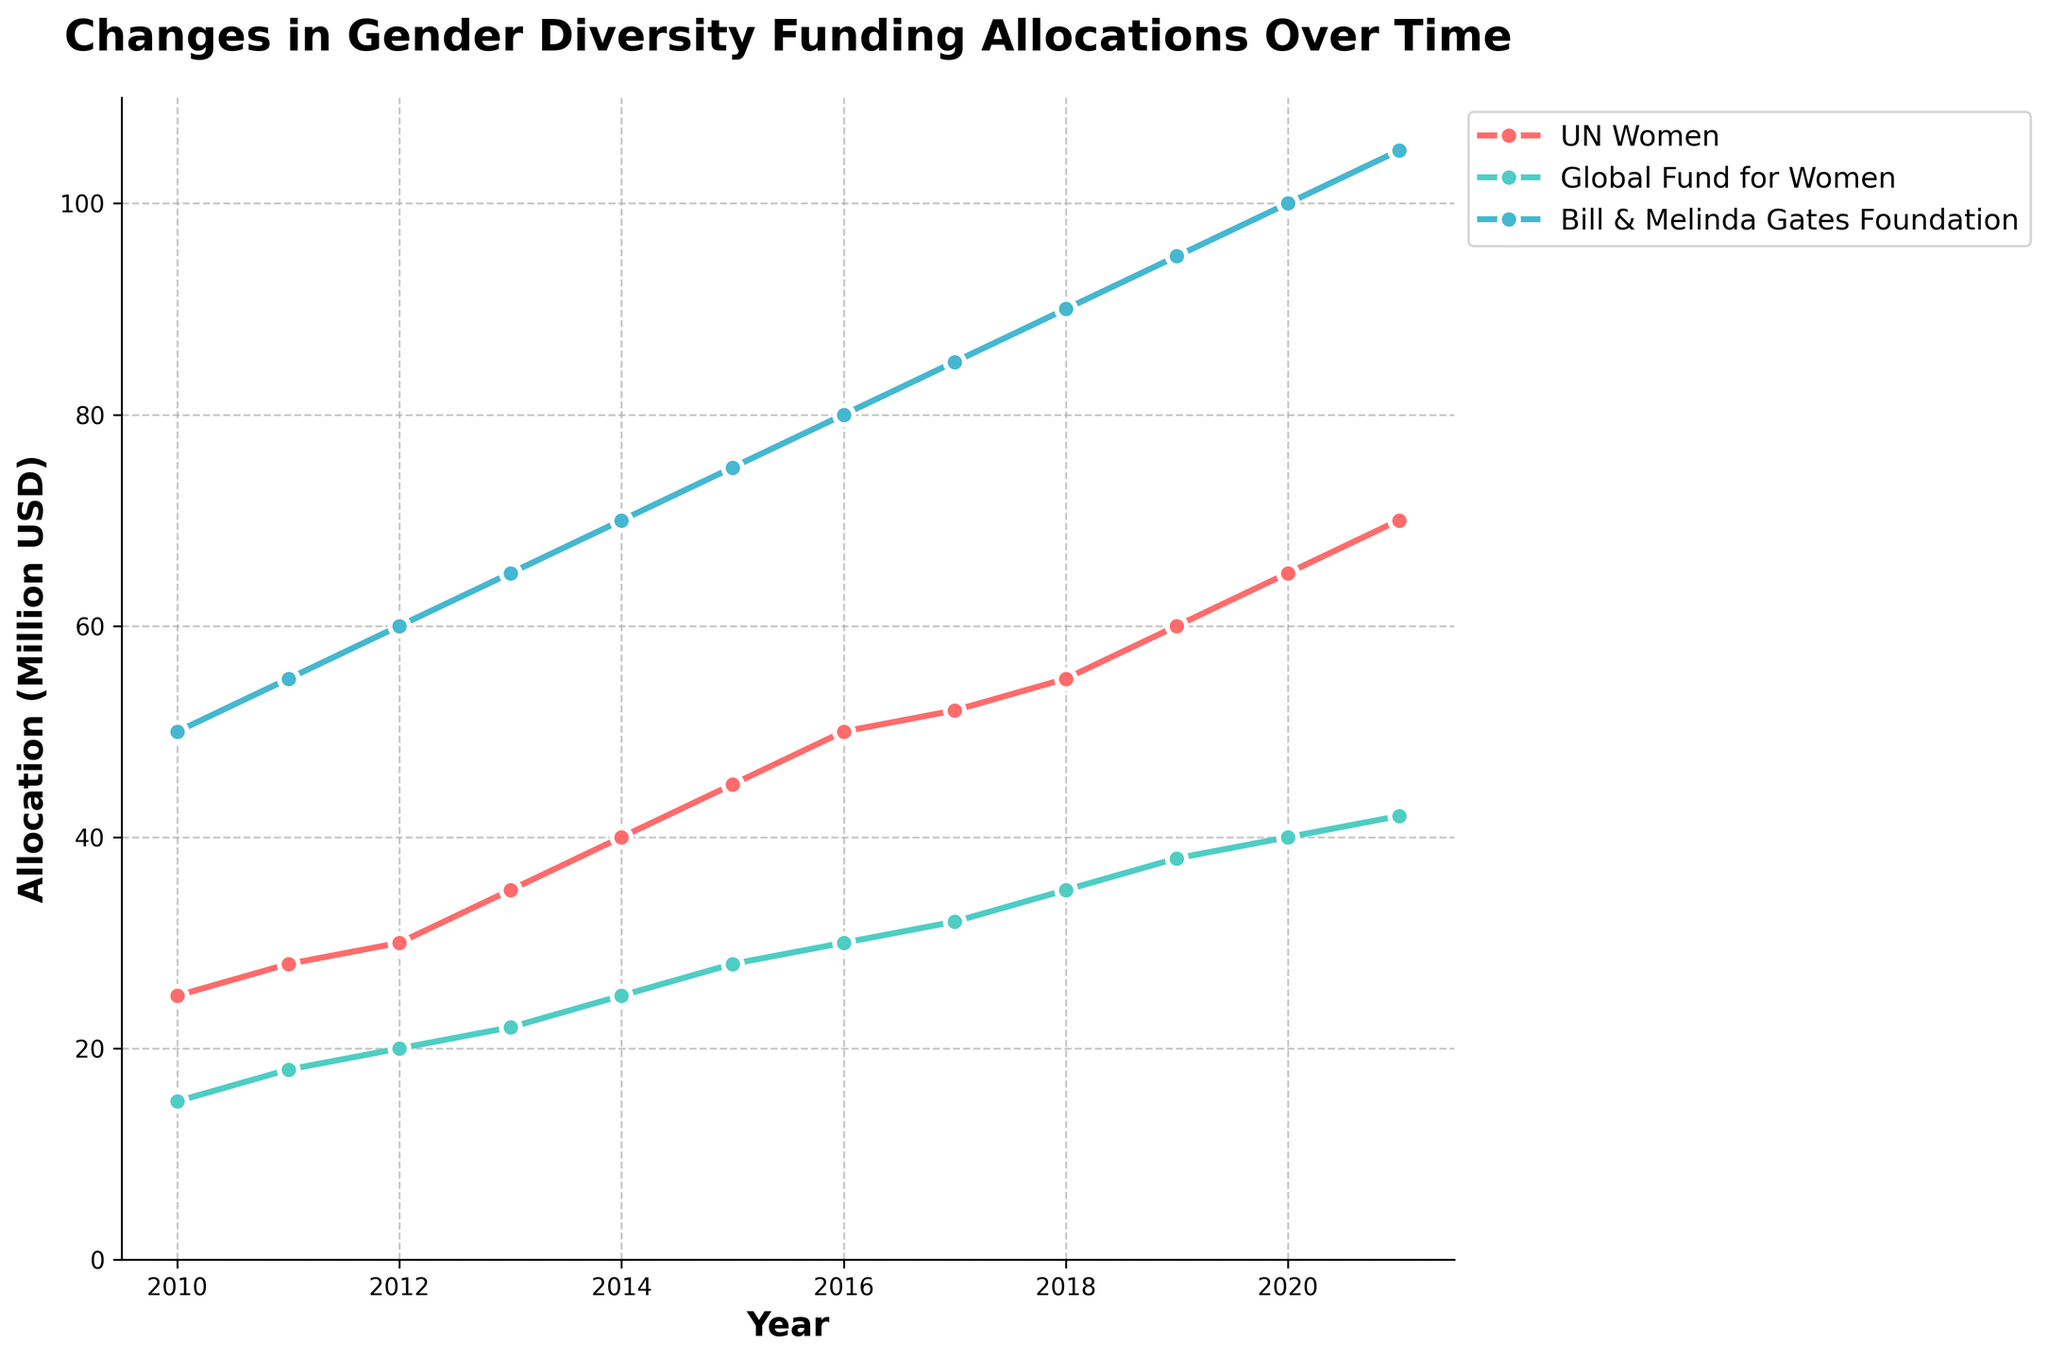What year saw the Bill & Melinda Gates Foundation allocate 85 million USD? Inspect the plot and identify when the allocation for the Bill & Melinda Gates Foundation reached 85 million USD.
Answer: 2017 Which organization had the highest allocation in 2021? Look at the allocations of all organizations in the year 2021 and identify the one with the highest allocation.
Answer: Bill & Melinda Gates Foundation How much did the Global Fund for Women increase their funding from 2015 to 2020? Check the allocation for the Global Fund for Women in 2015, which is 28 million USD, and then in 2020, which is 40 million USD. Subtract the 2015 allocation from the 2020 allocation: 40 - 28
Answer: 12 million USD Between which consecutive years did UN Women have the largest increase in funding? Compare the year-over-year increases for UN Women and identify the largest increase. The largest increase is from 2014 to 2015: 45 - 40 (5 million USD).
Answer: 2014 to 2015 Which organization had the smallest increase in funding from 2014 to 2015? Compare the increase in funding for all three organizations between 2014 and 2015. UN Women: 45 - 40 (5 million USD), Global Fund for Women: 28 - 25 (3 million USD), Bill & Melinda Gates Foundation: 75 - 70 (5 million USD). The smallest increase is for the Global Fund for Women.
Answer: Global Fund for Women How much more funding did the Bill & Melinda Gates Foundation receive in 2019 compared to the UN Women? Look at the allocations in 2019: Bill & Melinda Gates Foundation: 95 million USD, UN Women: 60 million USD. Subtract the UN Women allocation from the Bill & Melinda Gates Foundation allocation: 95 - 60
Answer: 35 million USD In which year did the Global Fund for Women first surpass 30 million USD in funding? Check the plot for the first year the Global Fund for Women's funding exceeds 30 million USD. This happens in 2016.
Answer: 2016 Calculate the average yearly allocation for UN Women over the entire period. Add the yearly allocations for UN Women from 2010 to 2021: 25 + 28 + 30 + 35 + 40 + 45 + 50 + 52 + 55 + 60 + 65 + 70 = 555. Divide by 12 (the number of years): 555 / 12
Answer: 46.25 million USD Which organization's funding shows the most consistent growth over time? Observe the trend lines for all three organizations. All organizations show year-over-year increases, but the Bill & Melinda Gates Foundation’s allocation grows consistently without any plateau or decrease.
Answer: Bill & Melinda Gates Foundation 